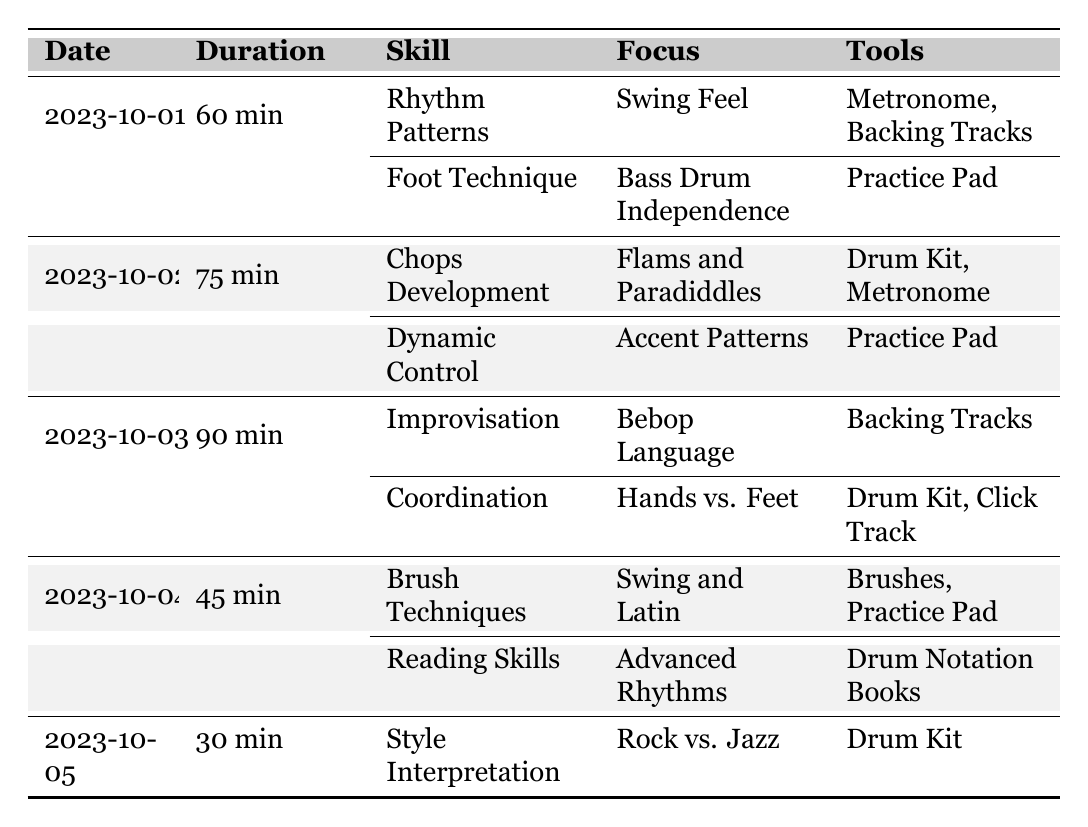What is the total duration of all practice sessions combined? To find the total duration, sum up the individual durations from each session: 60 + 75 + 90 + 45 + 30 = 300 minutes.
Answer: 300 minutes Which skill was focused on in the session dated October 2, 2023? The skills targeted on October 2, 2023, are Chops Development and Dynamic Control.
Answer: Chops Development, Dynamic Control How many different skills were targeted across all sessions? By counting the skills in each session: 2 (Oct 1) + 2 (Oct 2) + 2 (Oct 3) + 2 (Oct 4) + 1 (Oct 5) gives a total of 9 different skills.
Answer: 9 skills Did any session focus on reading skills? Yes, the session on October 4, 2023, included Reading Skills.
Answer: Yes What was the focus of the skill 'Foot Technique'? The focus for Foot Technique is Bass Drum Independence.
Answer: Bass Drum Independence Which session had the longest duration, and what was its specific duration? The session on October 3, 2023, had the longest duration of 90 minutes.
Answer: October 3, 90 minutes How many sessions targeted improvisation as a skill? Only one session, on October 3, 2023, targeted Improvisation.
Answer: 1 session What tools were used in the session that focused on Flams and Paradiddles? The tools used for Flams and Paradiddles were Drum Kit and Metronome.
Answer: Drum Kit, Metronome Which skill had the least duration dedicated to it? The shortest session on October 5, 2023, focused on Style Interpretation, which lasted 30 minutes.
Answer: Style Interpretation, 30 minutes What skill had a focus on 'Swing Feel'? The skill with a focus on Swing Feel is Rhythm Patterns.
Answer: Rhythm Patterns 